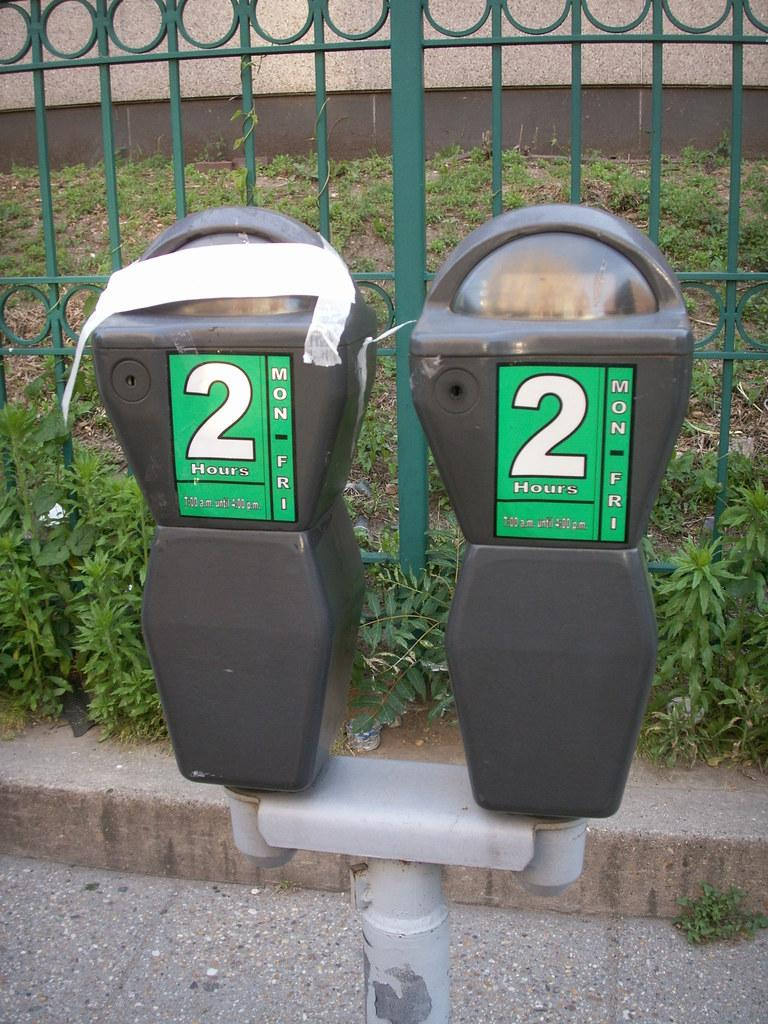Provide a one-sentence caption for the provided image. Two parking meters that say 2 Hours are by a green fence. 